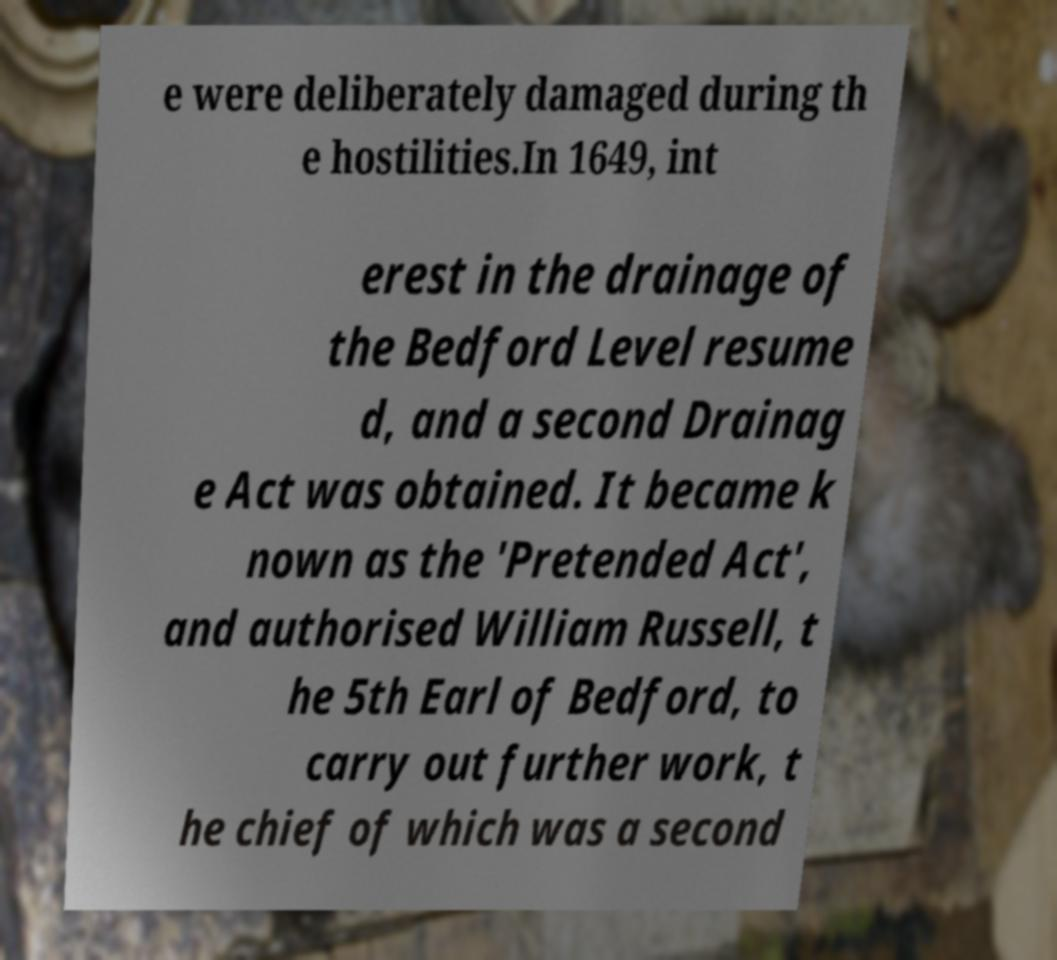Can you read and provide the text displayed in the image?This photo seems to have some interesting text. Can you extract and type it out for me? e were deliberately damaged during th e hostilities.In 1649, int erest in the drainage of the Bedford Level resume d, and a second Drainag e Act was obtained. It became k nown as the 'Pretended Act', and authorised William Russell, t he 5th Earl of Bedford, to carry out further work, t he chief of which was a second 